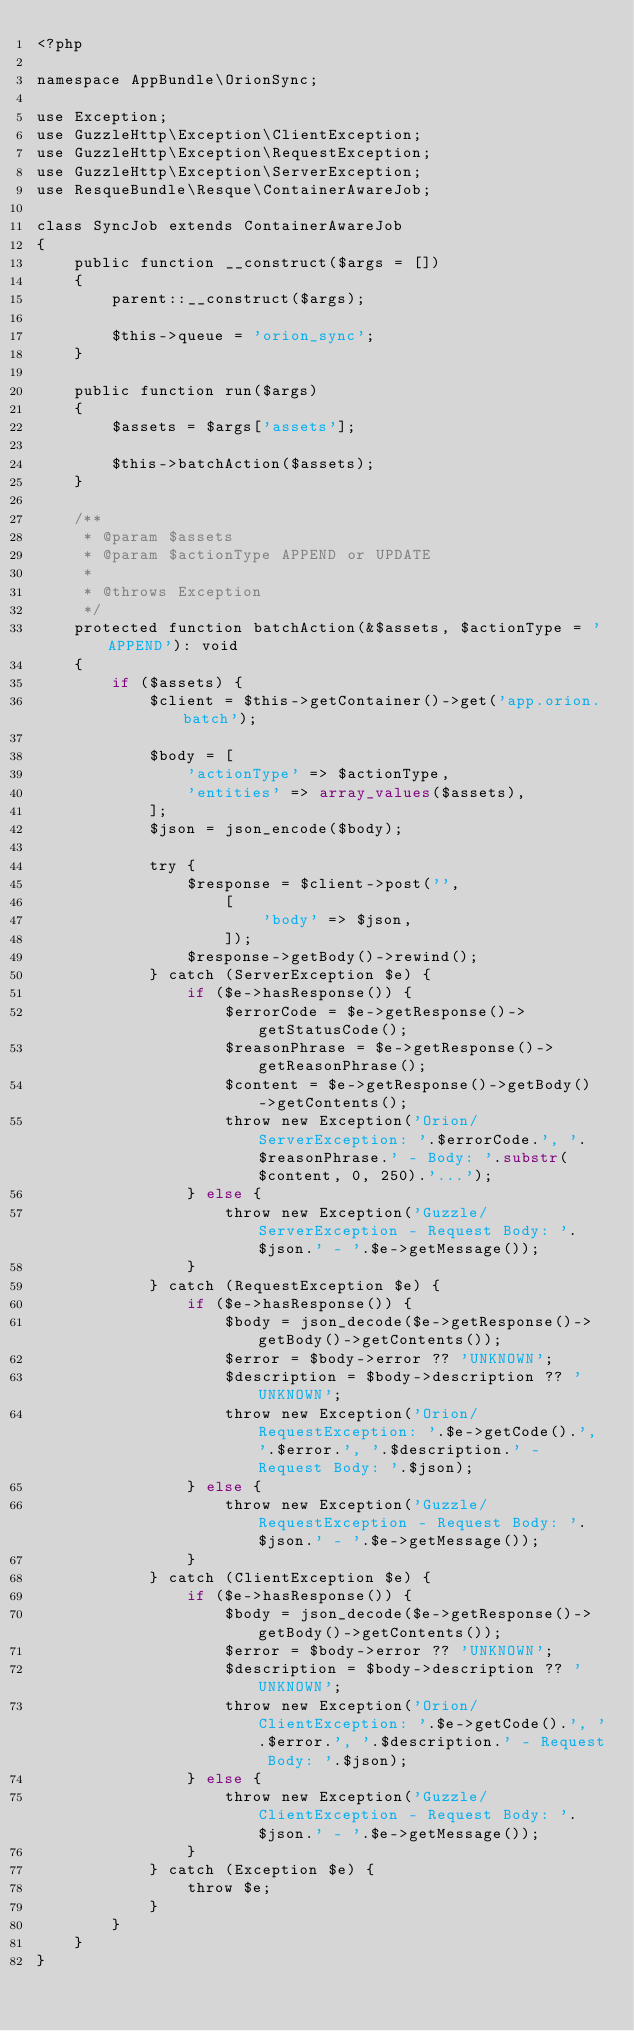<code> <loc_0><loc_0><loc_500><loc_500><_PHP_><?php

namespace AppBundle\OrionSync;

use Exception;
use GuzzleHttp\Exception\ClientException;
use GuzzleHttp\Exception\RequestException;
use GuzzleHttp\Exception\ServerException;
use ResqueBundle\Resque\ContainerAwareJob;

class SyncJob extends ContainerAwareJob
{
    public function __construct($args = [])
    {
        parent::__construct($args);

        $this->queue = 'orion_sync';
    }

    public function run($args)
    {
        $assets = $args['assets'];

        $this->batchAction($assets);
    }

    /**
     * @param $assets
     * @param $actionType APPEND or UPDATE
     *
     * @throws Exception
     */
    protected function batchAction(&$assets, $actionType = 'APPEND'): void
    {
        if ($assets) {
            $client = $this->getContainer()->get('app.orion.batch');

            $body = [
                'actionType' => $actionType,
                'entities' => array_values($assets),
            ];
            $json = json_encode($body);

            try {
                $response = $client->post('',
                    [
                        'body' => $json,
                    ]);
                $response->getBody()->rewind();
            } catch (ServerException $e) {
                if ($e->hasResponse()) {
                    $errorCode = $e->getResponse()->getStatusCode();
                    $reasonPhrase = $e->getResponse()->getReasonPhrase();
                    $content = $e->getResponse()->getBody()->getContents();
                    throw new Exception('Orion/ServerException: '.$errorCode.', '.$reasonPhrase.' - Body: '.substr($content, 0, 250).'...');
                } else {
                    throw new Exception('Guzzle/ServerException - Request Body: '.$json.' - '.$e->getMessage());
                }
            } catch (RequestException $e) {
                if ($e->hasResponse()) {
                    $body = json_decode($e->getResponse()->getBody()->getContents());
                    $error = $body->error ?? 'UNKNOWN';
                    $description = $body->description ?? 'UNKNOWN';
                    throw new Exception('Orion/RequestException: '.$e->getCode().', '.$error.', '.$description.' - Request Body: '.$json);
                } else {
                    throw new Exception('Guzzle/RequestException - Request Body: '.$json.' - '.$e->getMessage());
                }
            } catch (ClientException $e) {
                if ($e->hasResponse()) {
                    $body = json_decode($e->getResponse()->getBody()->getContents());
                    $error = $body->error ?? 'UNKNOWN';
                    $description = $body->description ?? 'UNKNOWN';
                    throw new Exception('Orion/ClientException: '.$e->getCode().', '.$error.', '.$description.' - Request Body: '.$json);
                } else {
                    throw new Exception('Guzzle/ClientException - Request Body: '.$json.' - '.$e->getMessage());
                }
            } catch (Exception $e) {
                throw $e;
            }
        }
    }
}
</code> 